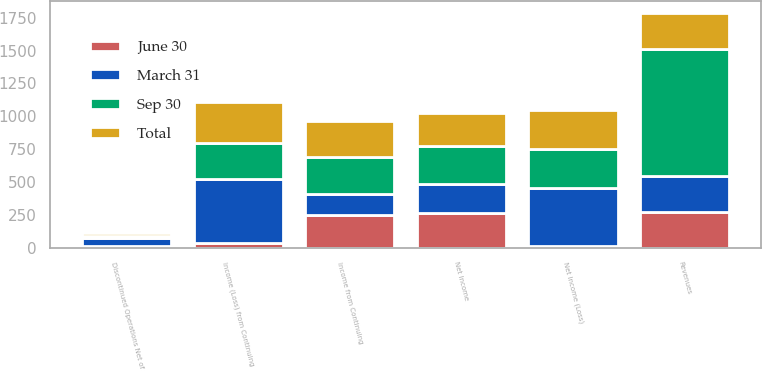<chart> <loc_0><loc_0><loc_500><loc_500><stacked_bar_chart><ecel><fcel>Revenues<fcel>Income from Continuing<fcel>Discontinued Operations Net of<fcel>Net Income<fcel>Income (Loss) from Continuing<fcel>Net Income (Loss)<nl><fcel>June 30<fcel>275<fcel>249<fcel>14<fcel>263<fcel>34<fcel>14<nl><fcel>Sep 30<fcel>965<fcel>275<fcel>17<fcel>292<fcel>269<fcel>294<nl><fcel>March 31<fcel>275<fcel>164<fcel>57<fcel>221<fcel>491<fcel>441<nl><fcel>Total<fcel>275<fcel>277<fcel>26<fcel>251<fcel>314<fcel>296<nl></chart> 